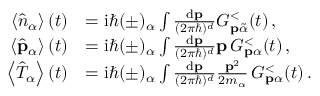Convert formula to latex. <formula><loc_0><loc_0><loc_500><loc_500>\begin{array} { r l } { \left \langle \hat { n } _ { \alpha } \right \rangle ( t ) } & { = i \hbar { ( } \pm ) _ { \alpha } \int \frac { d p } { ( 2 \pi \hbar { ) } ^ { d } } G _ { p \tilde { \alpha } } ^ { < } ( t ) \, , } \\ { \left \langle \hat { p } _ { \alpha } \right \rangle ( t ) } & { = i \hbar { ( } \pm ) _ { \alpha } \int \frac { d p } { ( 2 \pi \hbar { ) } ^ { d } } p \, G _ { p \alpha } ^ { < } ( t ) \, , } \\ { \left \langle \hat { T } _ { \alpha } \right \rangle ( t ) } & { = i \hbar { ( } \pm ) _ { \alpha } \int \frac { d p } { ( 2 \pi \hbar { ) } ^ { d } } \frac { p ^ { 2 } } { 2 m _ { \alpha } } \, G _ { p \alpha } ^ { < } ( t ) \, . } \end{array}</formula> 